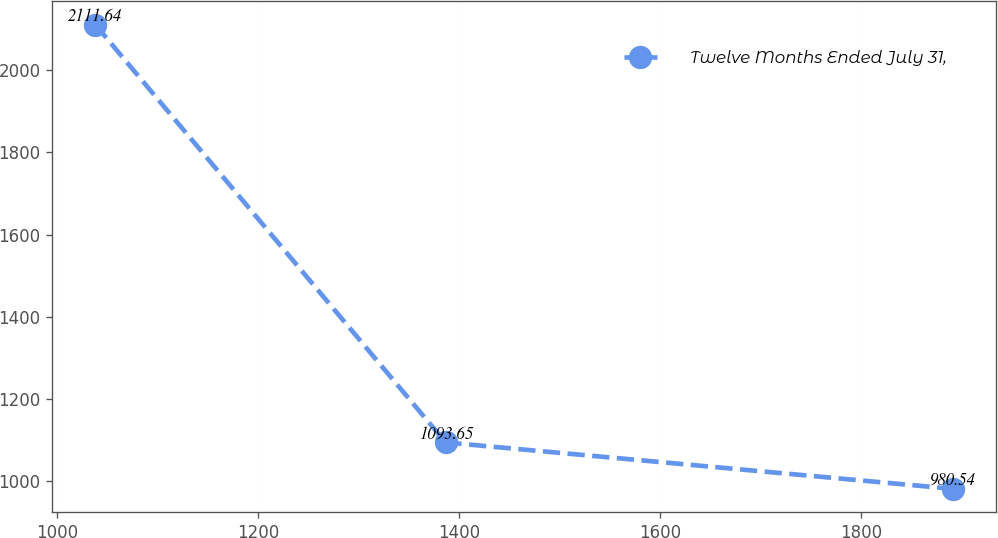<chart> <loc_0><loc_0><loc_500><loc_500><line_chart><ecel><fcel>Twelve Months Ended July 31,<nl><fcel>1038.04<fcel>2111.64<nl><fcel>1386.74<fcel>1093.65<nl><fcel>1891.35<fcel>980.54<nl></chart> 